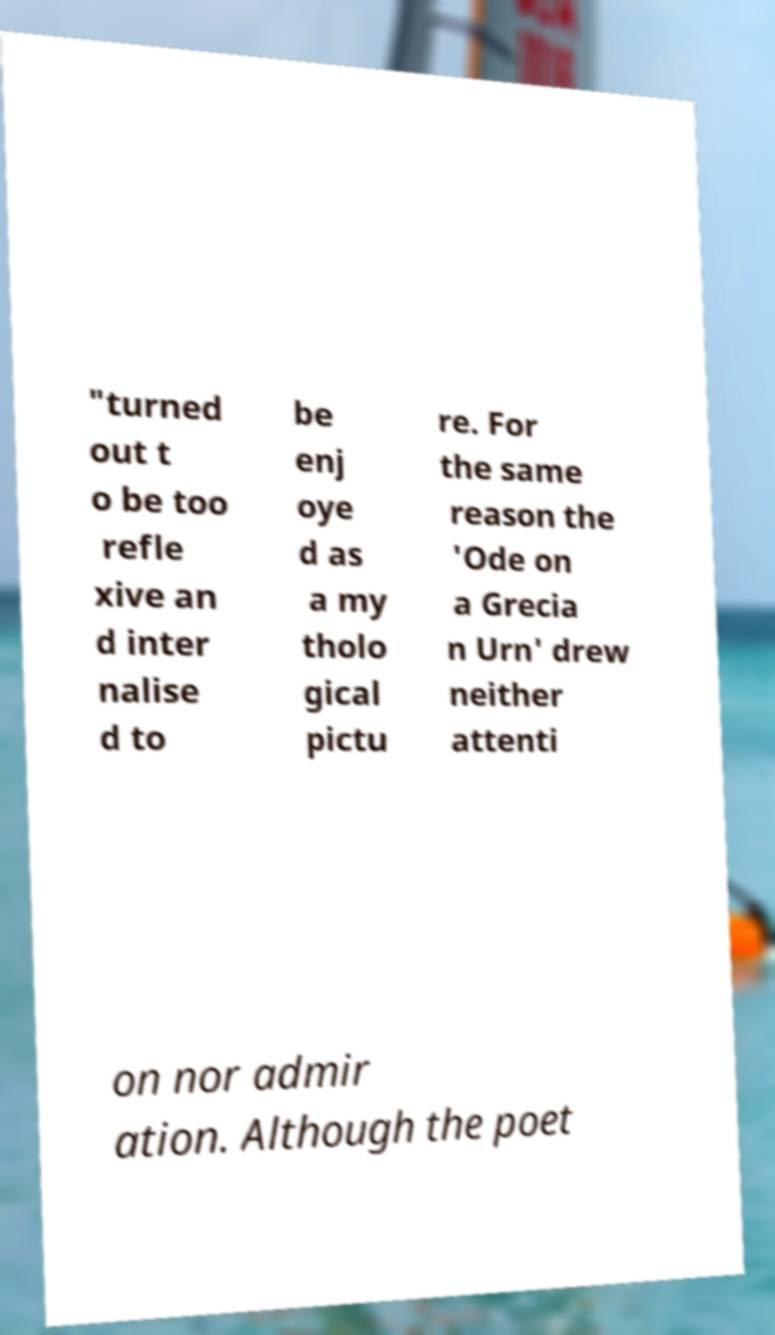I need the written content from this picture converted into text. Can you do that? "turned out t o be too refle xive an d inter nalise d to be enj oye d as a my tholo gical pictu re. For the same reason the 'Ode on a Grecia n Urn' drew neither attenti on nor admir ation. Although the poet 